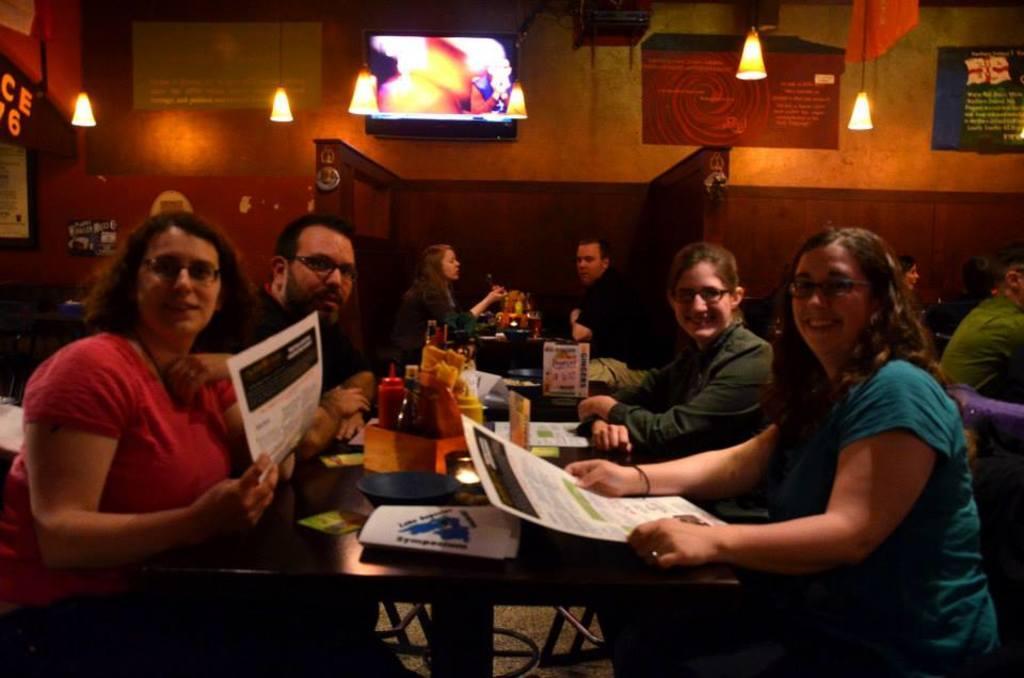Could you give a brief overview of what you see in this image? This image is taken in indoors. There are few people sitting on the chairs in this image. In the right side of the image a woman is sitting and holding a paper in her hand. In the background there is a wall with screen, frames with text on it and there are few lights. In the middle of the image there is a table with many things on it. 